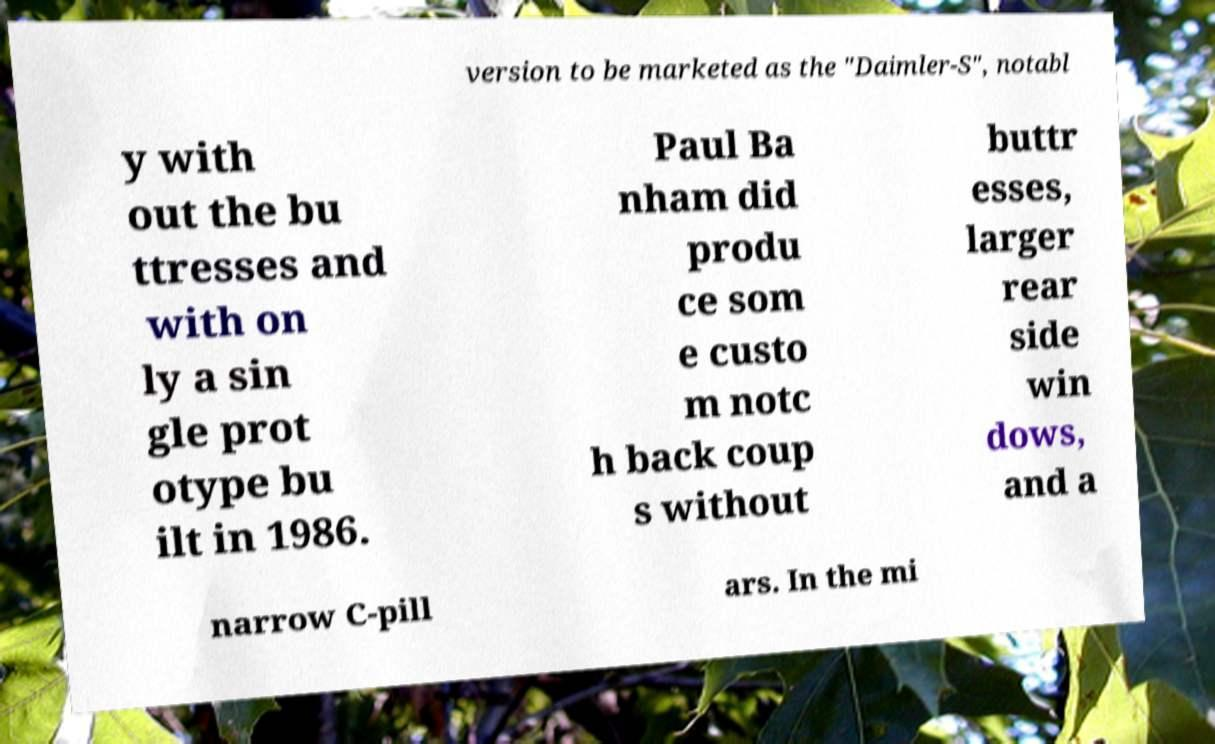What messages or text are displayed in this image? I need them in a readable, typed format. version to be marketed as the "Daimler-S", notabl y with out the bu ttresses and with on ly a sin gle prot otype bu ilt in 1986. Paul Ba nham did produ ce som e custo m notc h back coup s without buttr esses, larger rear side win dows, and a narrow C-pill ars. In the mi 